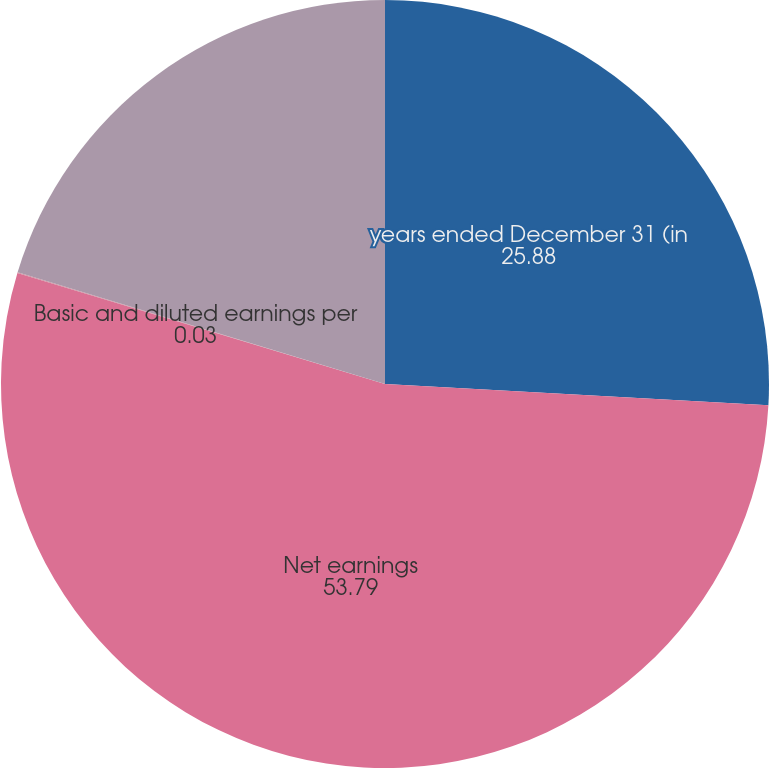Convert chart to OTSL. <chart><loc_0><loc_0><loc_500><loc_500><pie_chart><fcel>years ended December 31 (in<fcel>Net earnings<fcel>Basic and diluted earnings per<fcel>Basic and diluted average<nl><fcel>25.88%<fcel>53.79%<fcel>0.03%<fcel>20.3%<nl></chart> 